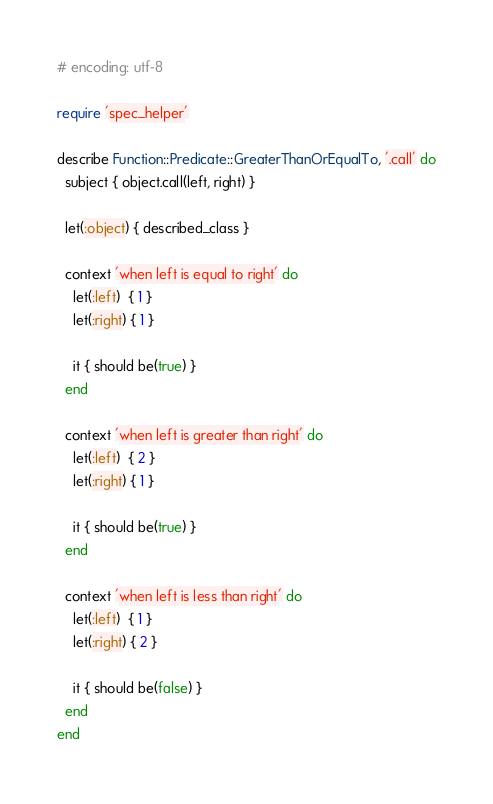<code> <loc_0><loc_0><loc_500><loc_500><_Ruby_># encoding: utf-8

require 'spec_helper'

describe Function::Predicate::GreaterThanOrEqualTo, '.call' do
  subject { object.call(left, right) }

  let(:object) { described_class }

  context 'when left is equal to right' do
    let(:left)  { 1 }
    let(:right) { 1 }

    it { should be(true) }
  end

  context 'when left is greater than right' do
    let(:left)  { 2 }
    let(:right) { 1 }

    it { should be(true) }
  end

  context 'when left is less than right' do
    let(:left)  { 1 }
    let(:right) { 2 }

    it { should be(false) }
  end
end
</code> 